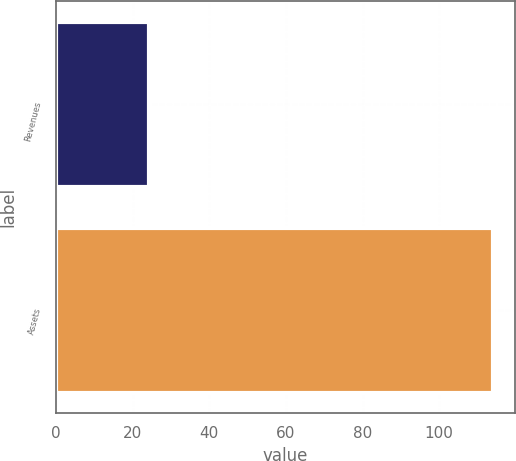Convert chart to OTSL. <chart><loc_0><loc_0><loc_500><loc_500><bar_chart><fcel>Revenues<fcel>Assets<nl><fcel>24.3<fcel>114<nl></chart> 